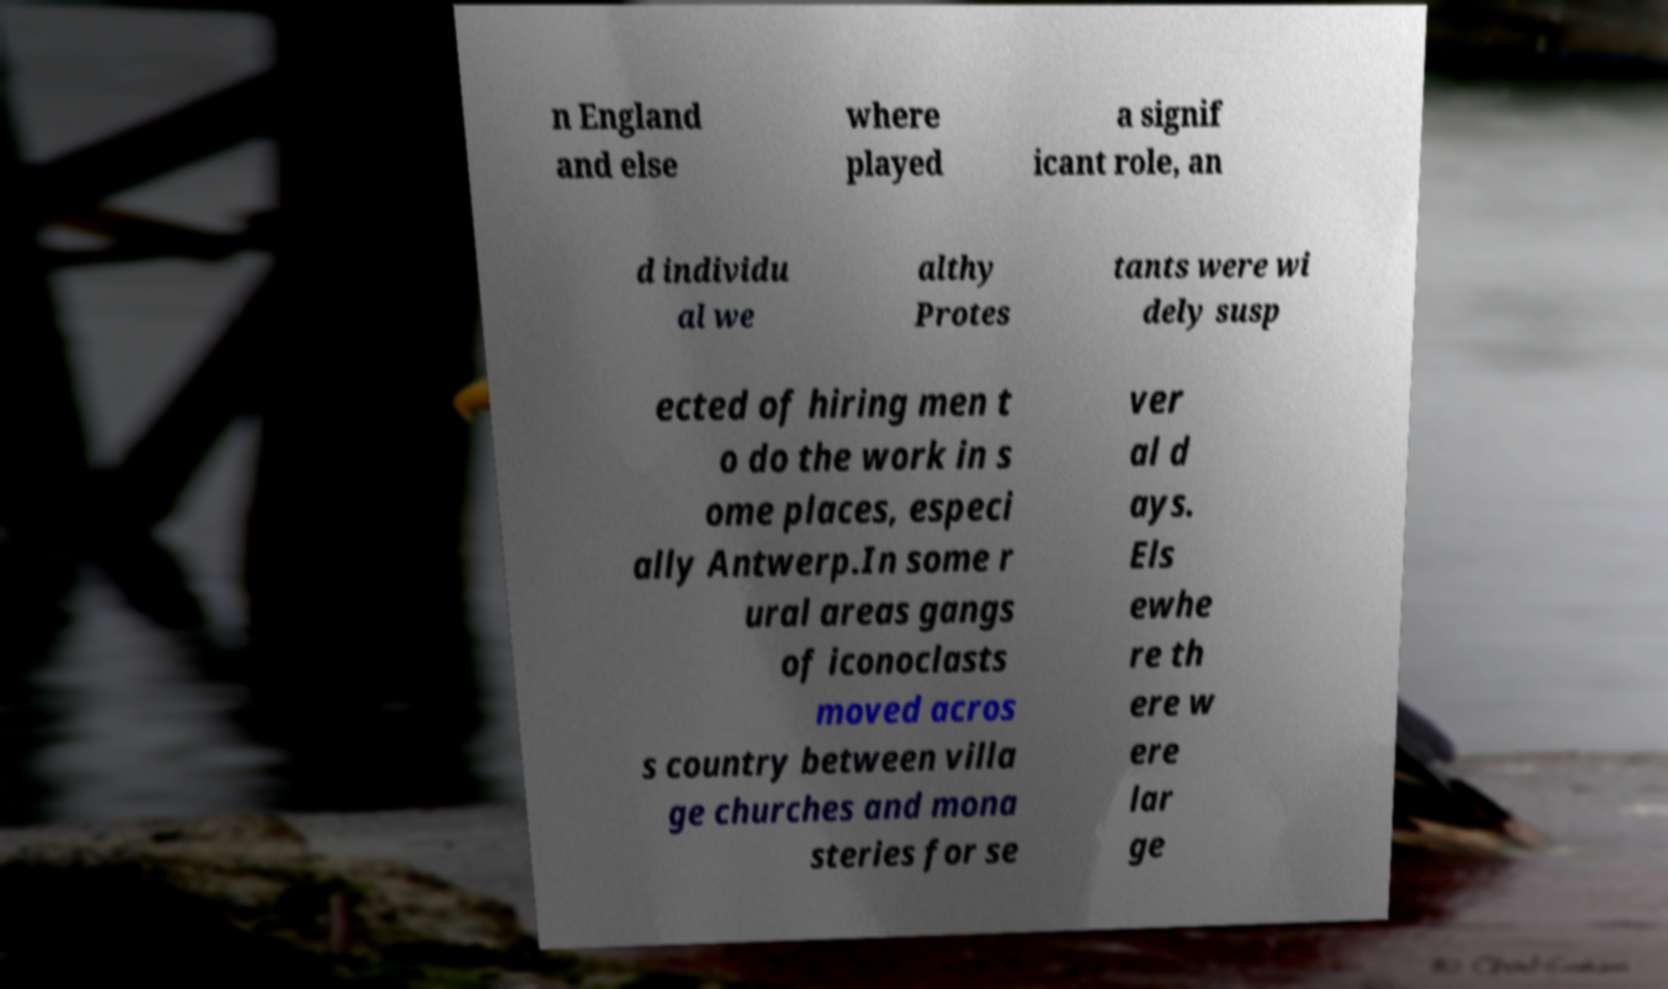Can you accurately transcribe the text from the provided image for me? n England and else where played a signif icant role, an d individu al we althy Protes tants were wi dely susp ected of hiring men t o do the work in s ome places, especi ally Antwerp.In some r ural areas gangs of iconoclasts moved acros s country between villa ge churches and mona steries for se ver al d ays. Els ewhe re th ere w ere lar ge 